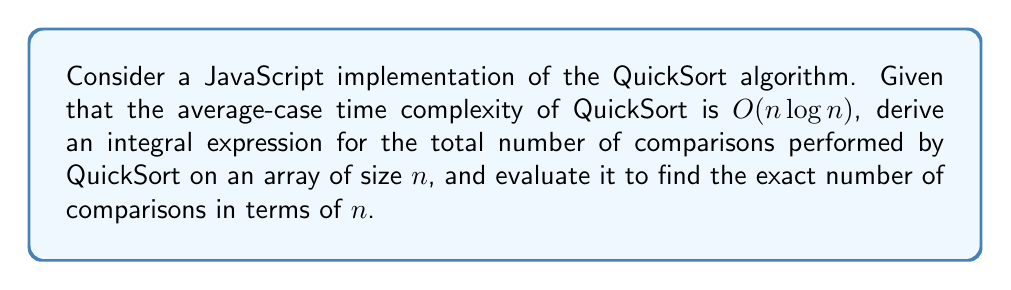Could you help me with this problem? Let's approach this step-by-step:

1) The average-case time complexity of QuickSort is $O(n \log n)$. This means the number of comparisons is proportional to $n \log n$.

2) Let $C(n)$ be the average number of comparisons for an array of size $n$. We can express this as:

   $$C(n) = k \cdot n \log n$$

   where $k$ is some constant.

3) To find the exact number of comparisons, we need to determine $k$. In QuickSort, the recurrence relation for the number of comparisons is:

   $$C(n) = n - 1 + \frac{2}{n} \sum_{i=0}^{n-1} C(i)$$

4) The integral method can be used to solve this recurrence. We assume $C(n)$ is a continuous function and replace the sum with an integral:

   $$C(x) = x - 1 + \frac{2}{x} \int_0^x C(t) dt$$

5) Differentiating both sides:

   $$C'(x) = 1 + \frac{2C(x)}{x} - \frac{2}{x^2} \int_0^x C(t) dt$$

6) Multiplying both sides by $x^2$:

   $$x^2C'(x) = x^2 + 2xC(x) - 2 \int_0^x C(t) dt$$

7) Differentiating again:

   $$2xC'(x) + x^2C''(x) = 2x + 2C(x) + 2xC'(x) - 2C(x)$$

8) Simplifying:

   $$x^2C''(x) = 2x$$

9) Solving this differential equation:

   $$C''(x) = \frac{2}{x}$$
   $$C'(x) = 2 \ln x + c_1$$
   $$C(x) = 2x \ln x - 2x + c_1x + c_2$$

10) Using the initial conditions $C(0) = 0$ and $C(1) = 0$, we find $c_1 = 2$ and $c_2 = 0$.

11) Therefore, the exact function for the number of comparisons is:

    $$C(n) = 2n \ln n - 2n + 2n = 2n \ln n$$
Answer: $2n \ln n$ 